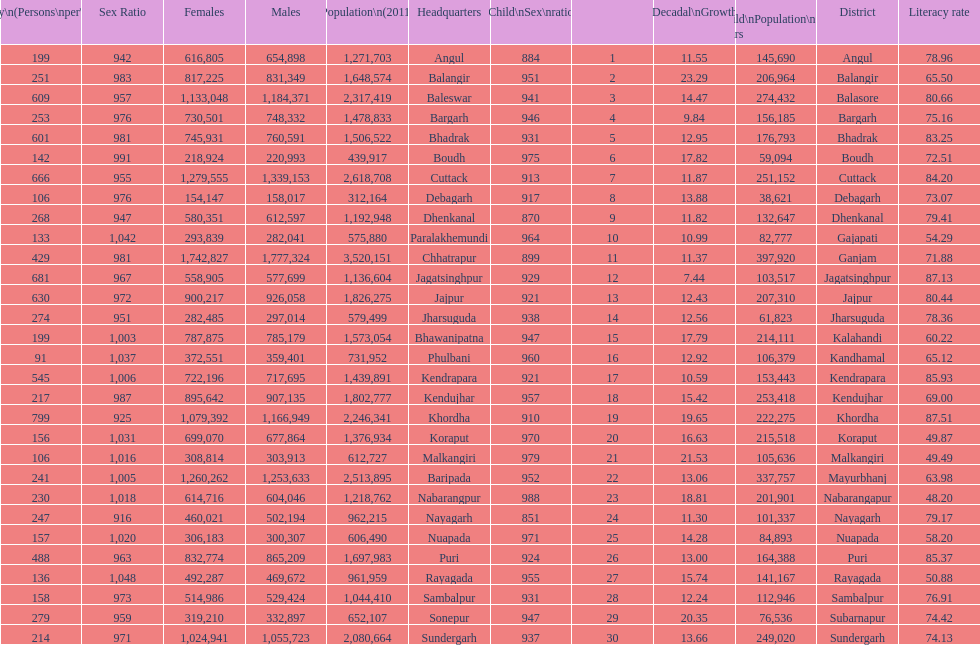What is the difference in child population between koraput and puri? 51,130. 